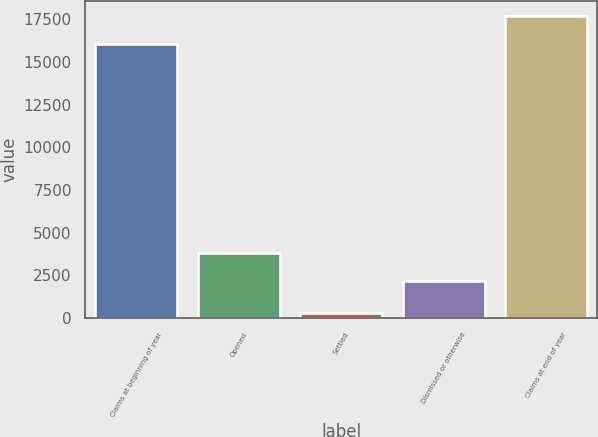<chart> <loc_0><loc_0><loc_500><loc_500><bar_chart><fcel>Claims at beginning of year<fcel>Opened<fcel>Settled<fcel>Dismissed or otherwise<fcel>Claims at end of year<nl><fcel>16080<fcel>3798.6<fcel>330<fcel>2199<fcel>17679.6<nl></chart> 